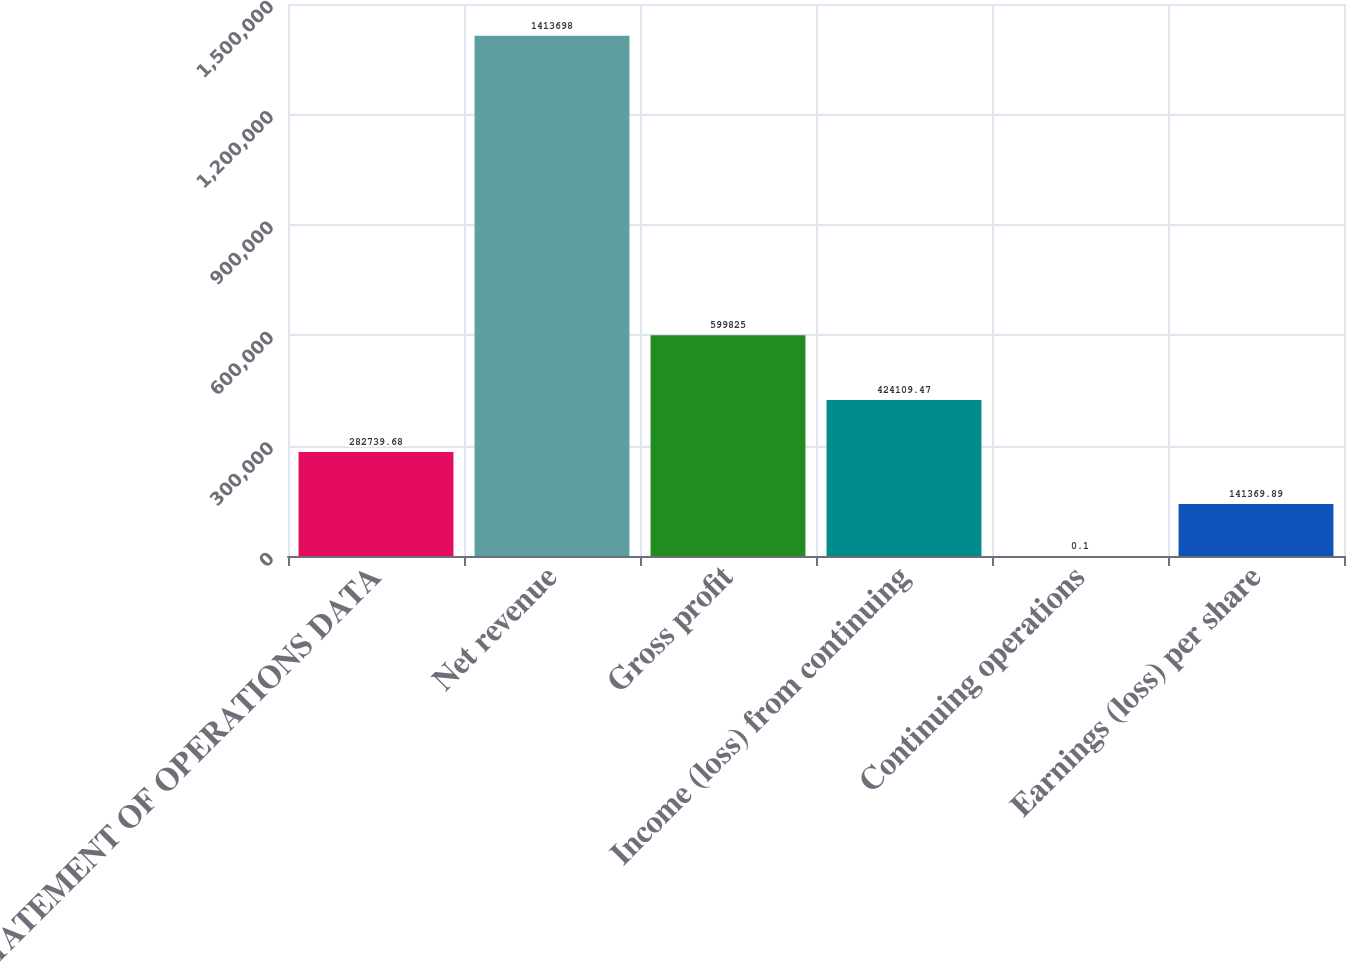<chart> <loc_0><loc_0><loc_500><loc_500><bar_chart><fcel>STATEMENT OF OPERATIONS DATA<fcel>Net revenue<fcel>Gross profit<fcel>Income (loss) from continuing<fcel>Continuing operations<fcel>Earnings (loss) per share<nl><fcel>282740<fcel>1.4137e+06<fcel>599825<fcel>424109<fcel>0.1<fcel>141370<nl></chart> 